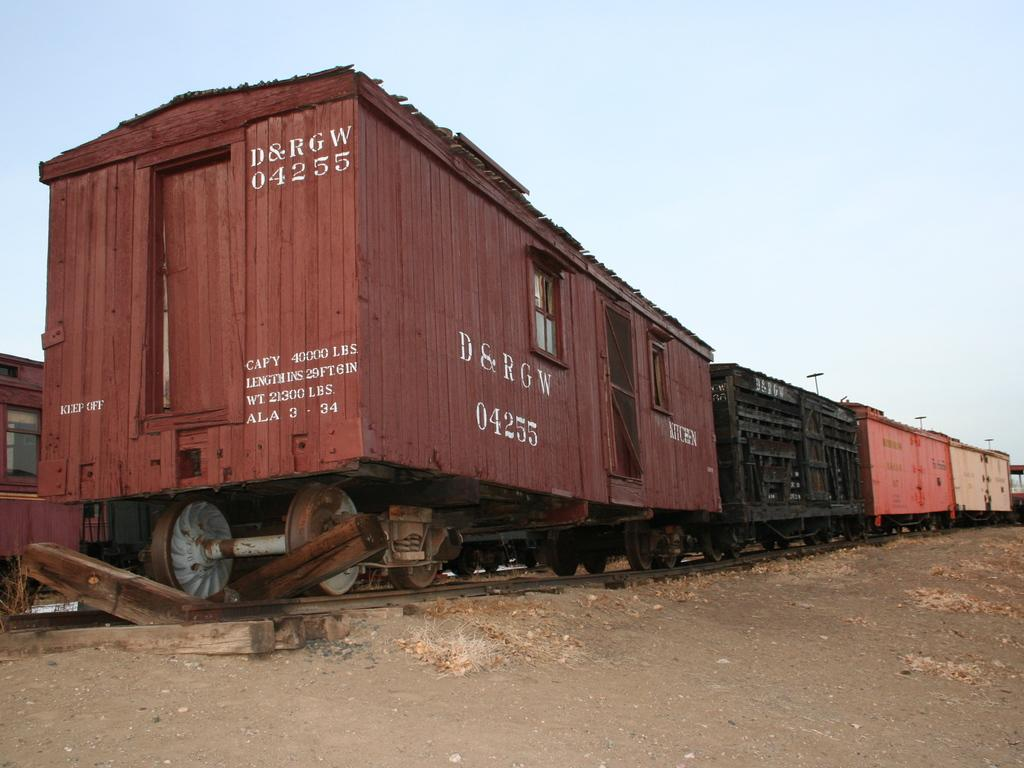<image>
Create a compact narrative representing the image presented. A string of railroad cars, the last of which says D&RGW on it. 